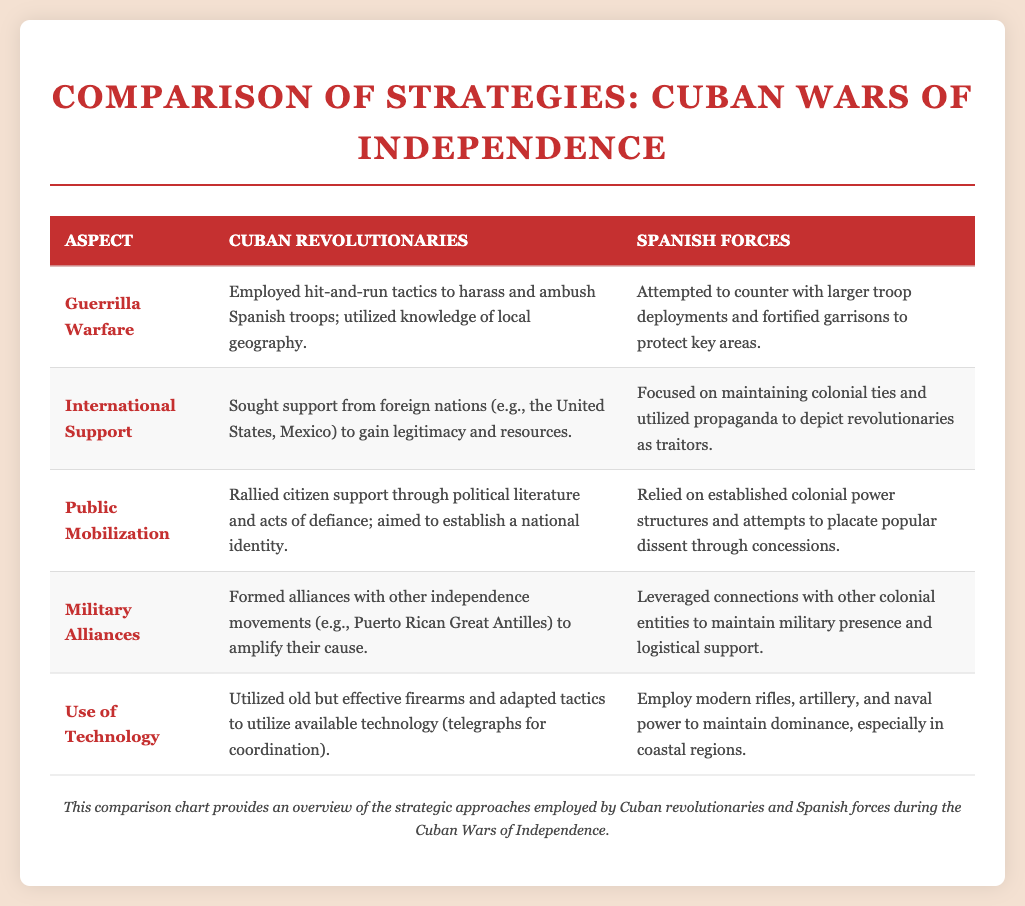What strategy did Cuban revolutionaries primarily employ? The Cuban revolutionaries employed guerrilla warfare as their primary strategy.
Answer: Guerrilla Warfare What did the Spanish forces rely on to counter guerrilla tactics? The Spanish forces relied on larger troop deployments and fortified garrisons to rebut guerrilla tactics.
Answer: Larger troop deployments Which external country did the Cuban revolutionaries seek support from? The Cuban revolutionaries sought support from the United States to gain resources and legitimacy.
Answer: United States What was the Spanish forces' approach to propaganda? The Spanish forces used propaganda to depict revolutionaries as traitors in an attempt to maintain control.
Answer: Depict revolutionaries as traitors What type of alliances did Cuban revolutionaries form? Cuban revolutionaries formed military alliances with other independence movements to strengthen their cause.
Answer: Military alliances What did the Cuban revolutionaries utilize for coordination? The Cuban revolutionaries adapted to use telegraphs for coordination in their military activities.
Answer: Telegraphs How did the Spanish forces maintain military presence? The Spanish forces leveraged connections with other colonial entities for military presence and support.
Answer: Connections with other colonial entities What was a strategy for public mobilization employed by Cuban revolutionaries? Cuban revolutionaries rallied citizen support through political literature and acts of defiance.
Answer: Political literature What type of technology did the Cuban revolutionaries utilize? Cuban revolutionaries utilized old but effective firearms for combat during the wars.
Answer: Old but effective firearms 